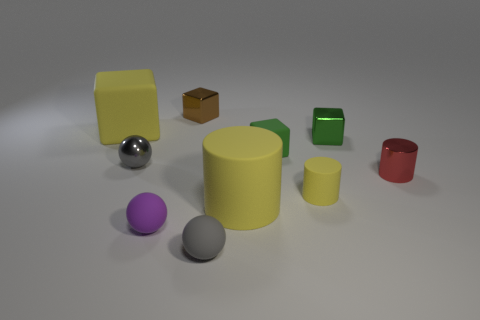Subtract 1 cylinders. How many cylinders are left? 2 Subtract all brown blocks. How many blocks are left? 3 Subtract all big rubber blocks. How many blocks are left? 3 Subtract all blue cubes. Subtract all brown cylinders. How many cubes are left? 4 Subtract all blocks. How many objects are left? 6 Add 1 small green rubber cylinders. How many small green rubber cylinders exist? 1 Subtract 0 yellow balls. How many objects are left? 10 Subtract all big yellow cubes. Subtract all small rubber blocks. How many objects are left? 8 Add 7 purple matte spheres. How many purple matte spheres are left? 8 